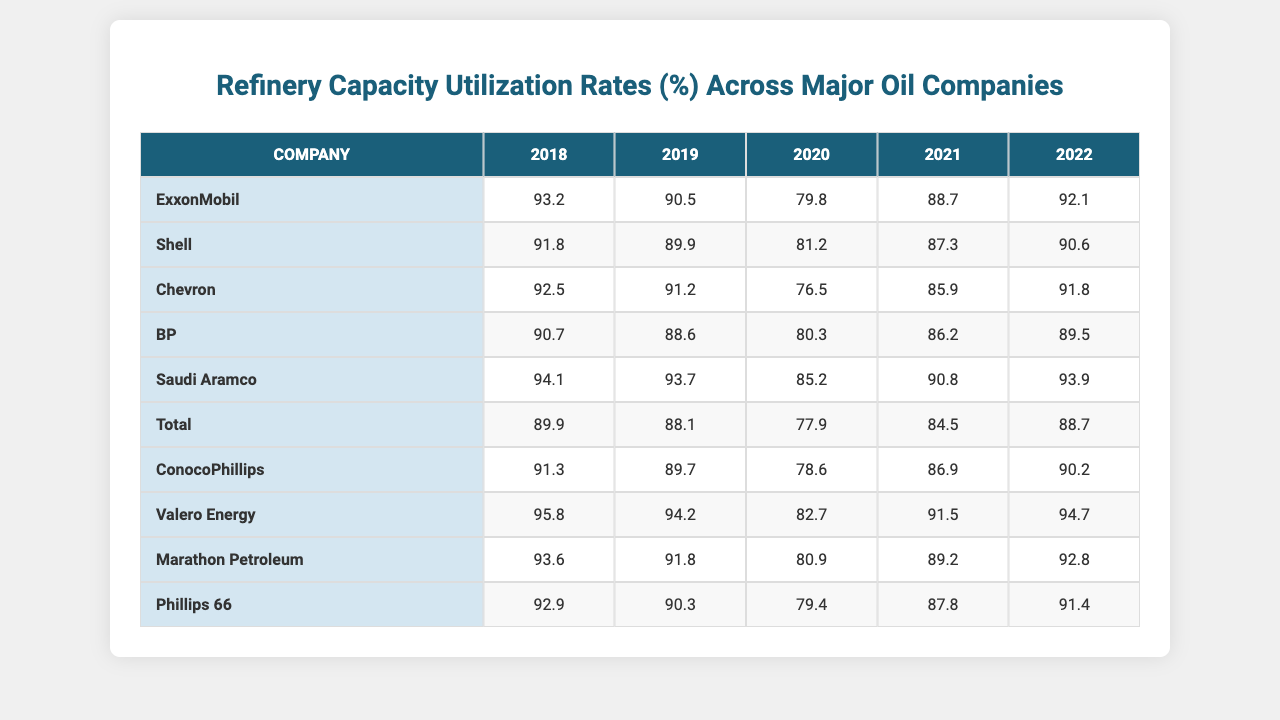What was the utilization rate of ExxonMobil in 2020? The table shows that the utilization rate for ExxonMobil in 2020 is listed under the year 2020, which is 79.8%.
Answer: 79.8% Which company had the highest utilization rate in 2019? By looking at the values for 2019, Valero Energy has the highest rate at 94.2%.
Answer: Valero Energy What was BP's utilization rate over the five years? BP's rates are 90.7% for 2018, 88.6% for 2019, 80.3% for 2020, 86.2% for 2021, and 89.5% for 2022.
Answer: 90.7%, 88.6%, 80.3%, 86.2%, 89.5% How many companies have an average utilization rate above 90% from 2018 to 2022? First, calculate the average for each company. ExxonMobil, Valero Energy, and Saudi Aramco all have averages above 90% (93.2%, 95.8%, and 93.9%, respectively). So, there are three companies.
Answer: 3 What is the average utilization rate for Chevron from 2018 to 2022? The rates for Chevron from 2018 to 2022 are 92.5%, 91.2%, 76.5%, 85.9%, and 91.8%. Adding these together gives 437.9%. Dividing by 5 results in an average of 87.58%.
Answer: 87.58% Did Total ever have a utilization rate over 90% in the years provided? Reviewing the rates for Total, 89.9% in 2018, 88.1% in 2019, 77.9% in 2020, 84.5% in 2021, and 88.7% in 2022, we find that it never reached 90%.
Answer: No Which company's utilization rate showed the greatest increase from 2020 to 2022? For 2020, Valero Energy's utilization rate was 82.7%, which increased to 94.7% in 2022. This is an increase of 12%. Calculating the increases for all companies, Valero has the highest.
Answer: Valero Energy What is the median utilization rate for all companies in 2021? The values for all companies in 2021 are: 88.7%, 87.3%, 85.9%, 86.2%, 90.8%, 84.5%, 86.9%, 91.5%, 89.2%, 87.8%. Arranging these values gives us a median of 87.9%.
Answer: 87.9% Which company had a utilization rate of 90.6% in 2022? The table indicates that Shell had a utilization rate of 90.6% in 2022.
Answer: Shell Which company's utilization rate decreased the most from 2018 to 2022? Analyzing the rates, Chevron had 92.5% in 2018 and dropped to 91.8% in 2022. The decrease is only 0.7%. However, Phillips 66 went from 92.9% to 91.4%, a decrease of 1.5%. Thus, Phillips 66 had the most significant decline.
Answer: Phillips 66 